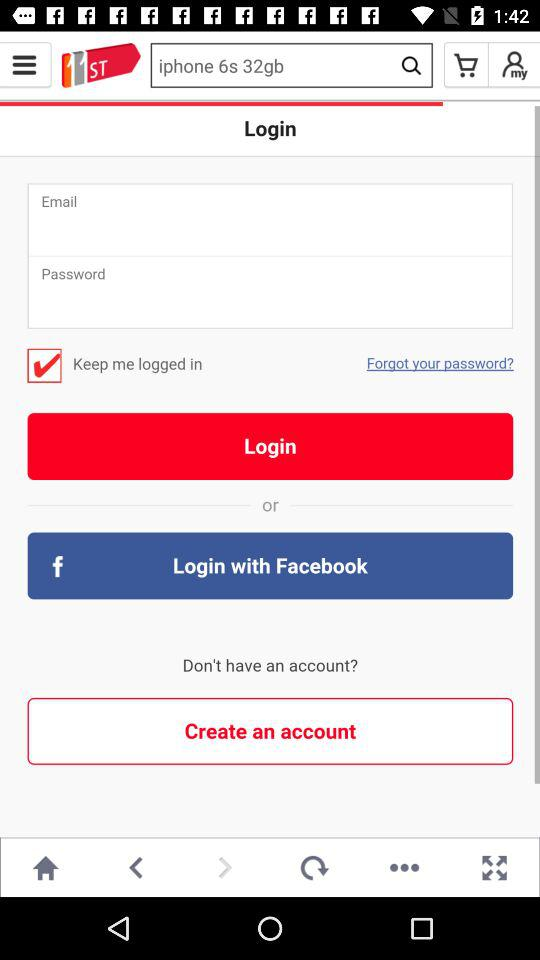What's the selected tab? The selected tab is "HOME". 